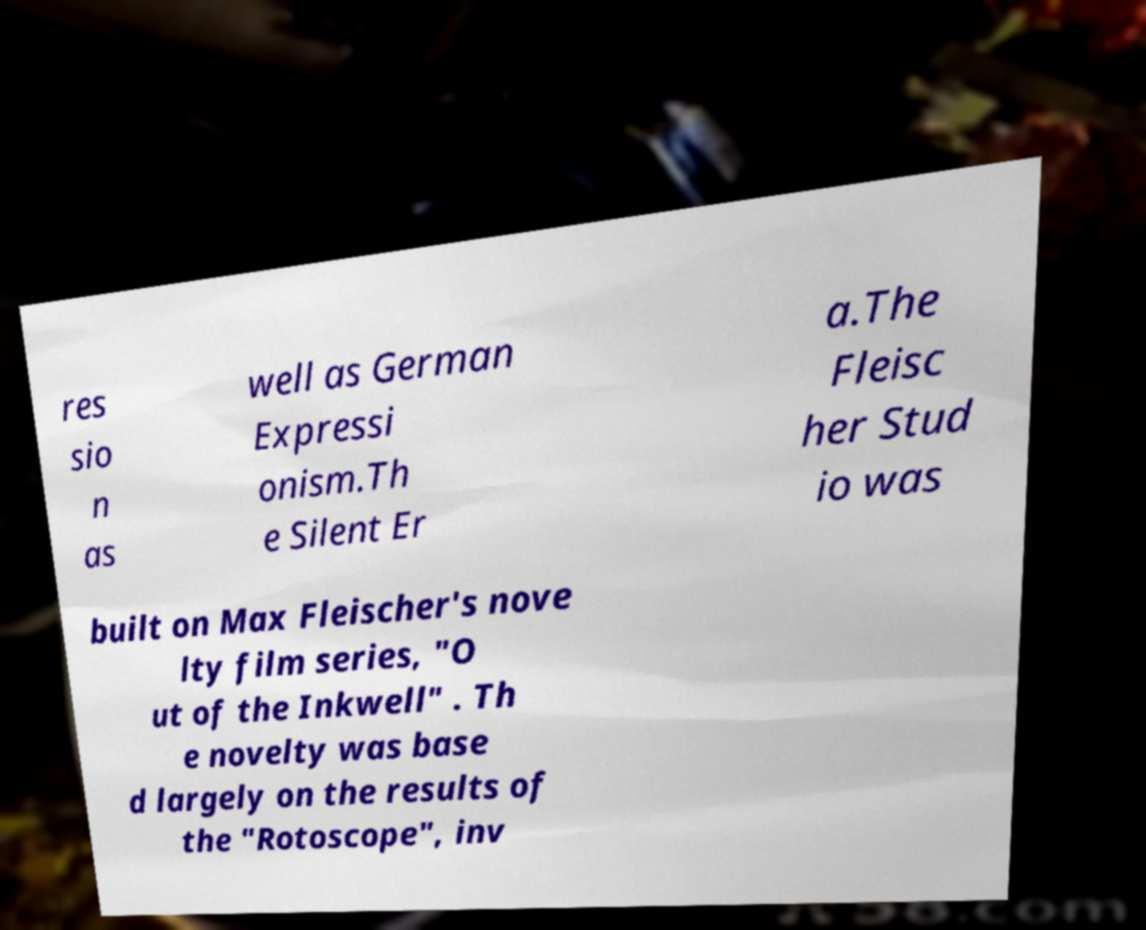What messages or text are displayed in this image? I need them in a readable, typed format. res sio n as well as German Expressi onism.Th e Silent Er a.The Fleisc her Stud io was built on Max Fleischer's nove lty film series, "O ut of the Inkwell" . Th e novelty was base d largely on the results of the "Rotoscope", inv 